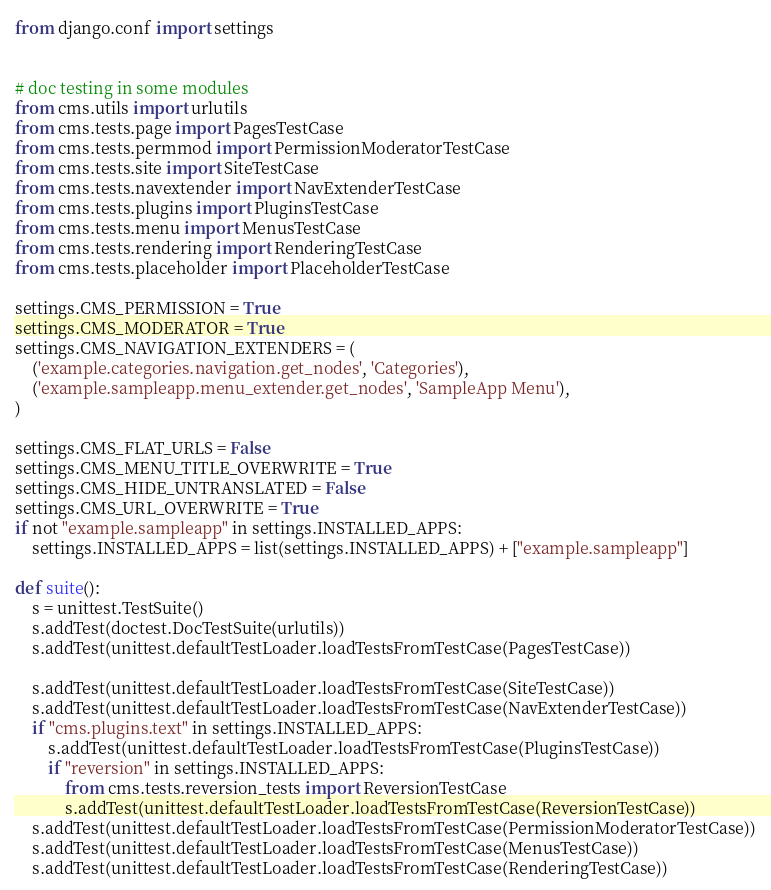<code> <loc_0><loc_0><loc_500><loc_500><_Python_>from django.conf import settings


# doc testing in some modules
from cms.utils import urlutils
from cms.tests.page import PagesTestCase
from cms.tests.permmod import PermissionModeratorTestCase
from cms.tests.site import SiteTestCase
from cms.tests.navextender import NavExtenderTestCase
from cms.tests.plugins import PluginsTestCase
from cms.tests.menu import MenusTestCase
from cms.tests.rendering import RenderingTestCase
from cms.tests.placeholder import PlaceholderTestCase

settings.CMS_PERMISSION = True
settings.CMS_MODERATOR = True
settings.CMS_NAVIGATION_EXTENDERS = (
    ('example.categories.navigation.get_nodes', 'Categories'),
    ('example.sampleapp.menu_extender.get_nodes', 'SampleApp Menu'),
)

settings.CMS_FLAT_URLS = False
settings.CMS_MENU_TITLE_OVERWRITE = True
settings.CMS_HIDE_UNTRANSLATED = False
settings.CMS_URL_OVERWRITE = True
if not "example.sampleapp" in settings.INSTALLED_APPS:
    settings.INSTALLED_APPS = list(settings.INSTALLED_APPS) + ["example.sampleapp"]

def suite():
    s = unittest.TestSuite()
    s.addTest(doctest.DocTestSuite(urlutils))
    s.addTest(unittest.defaultTestLoader.loadTestsFromTestCase(PagesTestCase))
    
    s.addTest(unittest.defaultTestLoader.loadTestsFromTestCase(SiteTestCase))
    s.addTest(unittest.defaultTestLoader.loadTestsFromTestCase(NavExtenderTestCase))
    if "cms.plugins.text" in settings.INSTALLED_APPS:
        s.addTest(unittest.defaultTestLoader.loadTestsFromTestCase(PluginsTestCase))
        if "reversion" in settings.INSTALLED_APPS:
            from cms.tests.reversion_tests import ReversionTestCase
            s.addTest(unittest.defaultTestLoader.loadTestsFromTestCase(ReversionTestCase))
    s.addTest(unittest.defaultTestLoader.loadTestsFromTestCase(PermissionModeratorTestCase))
    s.addTest(unittest.defaultTestLoader.loadTestsFromTestCase(MenusTestCase))
    s.addTest(unittest.defaultTestLoader.loadTestsFromTestCase(RenderingTestCase))</code> 